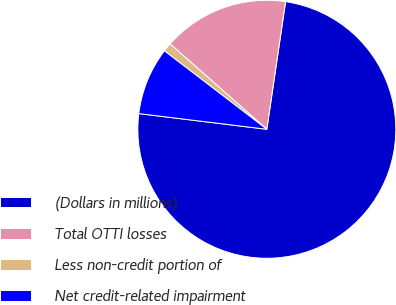<chart> <loc_0><loc_0><loc_500><loc_500><pie_chart><fcel>(Dollars in millions)<fcel>Total OTTI losses<fcel>Less non-credit portion of<fcel>Net credit-related impairment<nl><fcel>74.62%<fcel>15.81%<fcel>1.11%<fcel>8.46%<nl></chart> 